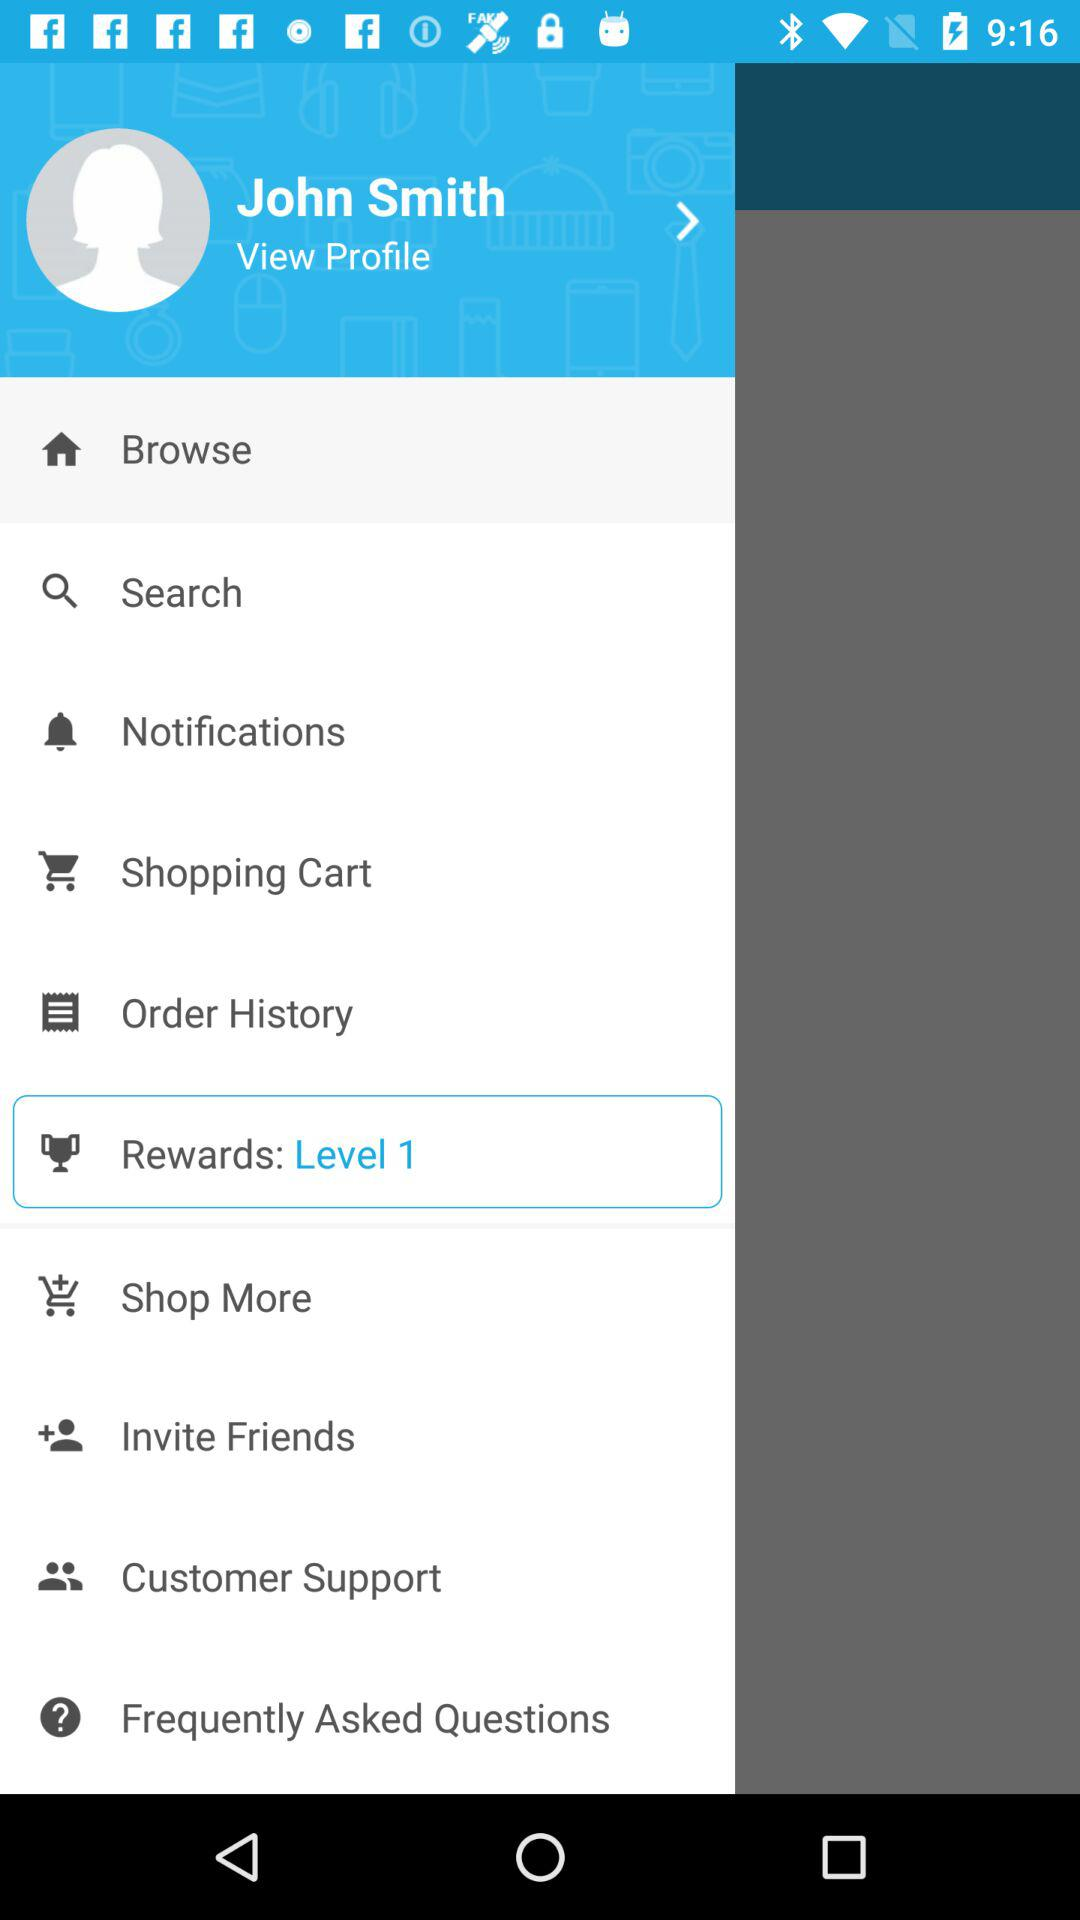Which items were purchased in the past?
When the provided information is insufficient, respond with <no answer>. <no answer> 